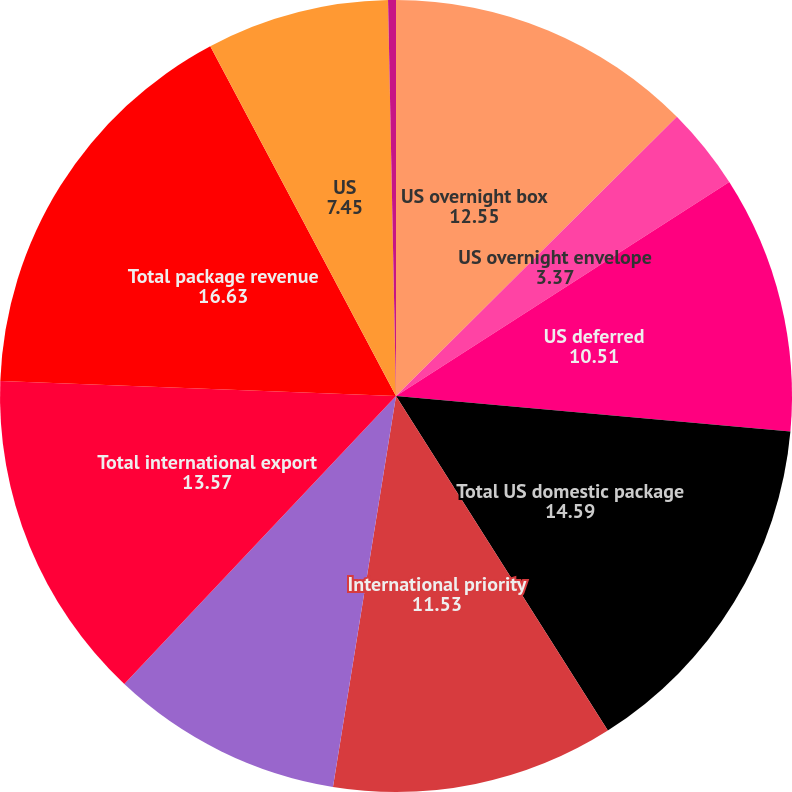Convert chart. <chart><loc_0><loc_0><loc_500><loc_500><pie_chart><fcel>US overnight box<fcel>US overnight envelope<fcel>US deferred<fcel>Total US domestic package<fcel>International priority<fcel>International economy<fcel>Total international export<fcel>Total package revenue<fcel>US<fcel>Other<nl><fcel>12.55%<fcel>3.37%<fcel>10.51%<fcel>14.59%<fcel>11.53%<fcel>9.49%<fcel>13.57%<fcel>16.63%<fcel>7.45%<fcel>0.32%<nl></chart> 